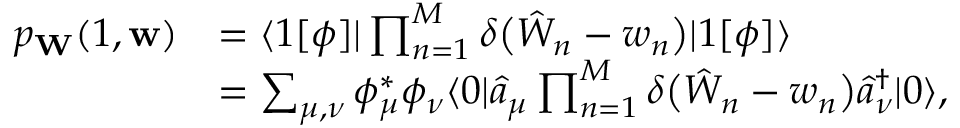<formula> <loc_0><loc_0><loc_500><loc_500>\begin{array} { r l } { p _ { W } ( 1 , w ) } & { = \langle 1 [ \phi ] | \prod _ { n = 1 } ^ { M } \delta \left ( \hat { W } _ { n } - w _ { n } \right ) | 1 [ \phi ] \rangle } \\ & { = \sum _ { \mu , \nu } \phi _ { \mu } ^ { * } \phi _ { \nu } \langle 0 | \hat { a } _ { \mu } \prod _ { n = 1 } ^ { M } \delta \left ( \hat { W } _ { n } - w _ { n } \right ) \hat { a } _ { \nu } ^ { \dagger } | 0 \rangle , } \end{array}</formula> 